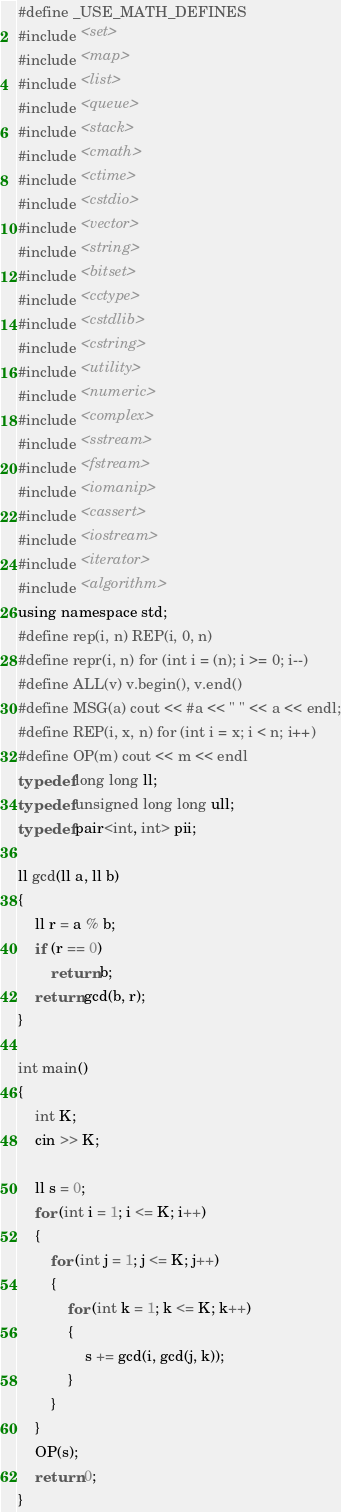<code> <loc_0><loc_0><loc_500><loc_500><_C_>#define _USE_MATH_DEFINES
#include <set>
#include <map>
#include <list>
#include <queue>
#include <stack>
#include <cmath>
#include <ctime>
#include <cstdio>
#include <vector>
#include <string>
#include <bitset>
#include <cctype>
#include <cstdlib>
#include <cstring>
#include <utility>
#include <numeric>
#include <complex>
#include <sstream>
#include <fstream>
#include <iomanip>
#include <cassert>
#include <iostream>
#include <iterator>
#include <algorithm>
using namespace std;
#define rep(i, n) REP(i, 0, n)
#define repr(i, n) for (int i = (n); i >= 0; i--)
#define ALL(v) v.begin(), v.end()
#define MSG(a) cout << #a << " " << a << endl;
#define REP(i, x, n) for (int i = x; i < n; i++)
#define OP(m) cout << m << endl
typedef long long ll;
typedef unsigned long long ull;
typedef pair<int, int> pii;

ll gcd(ll a, ll b)
{
    ll r = a % b;
    if (r == 0)
        return b;
    return gcd(b, r);
}

int main()
{
    int K;
    cin >> K;

    ll s = 0;
    for (int i = 1; i <= K; i++)
    {
        for (int j = 1; j <= K; j++)
        {
            for (int k = 1; k <= K; k++)
            {
                s += gcd(i, gcd(j, k));
            }
        }
    }
    OP(s);
    return 0;
}</code> 